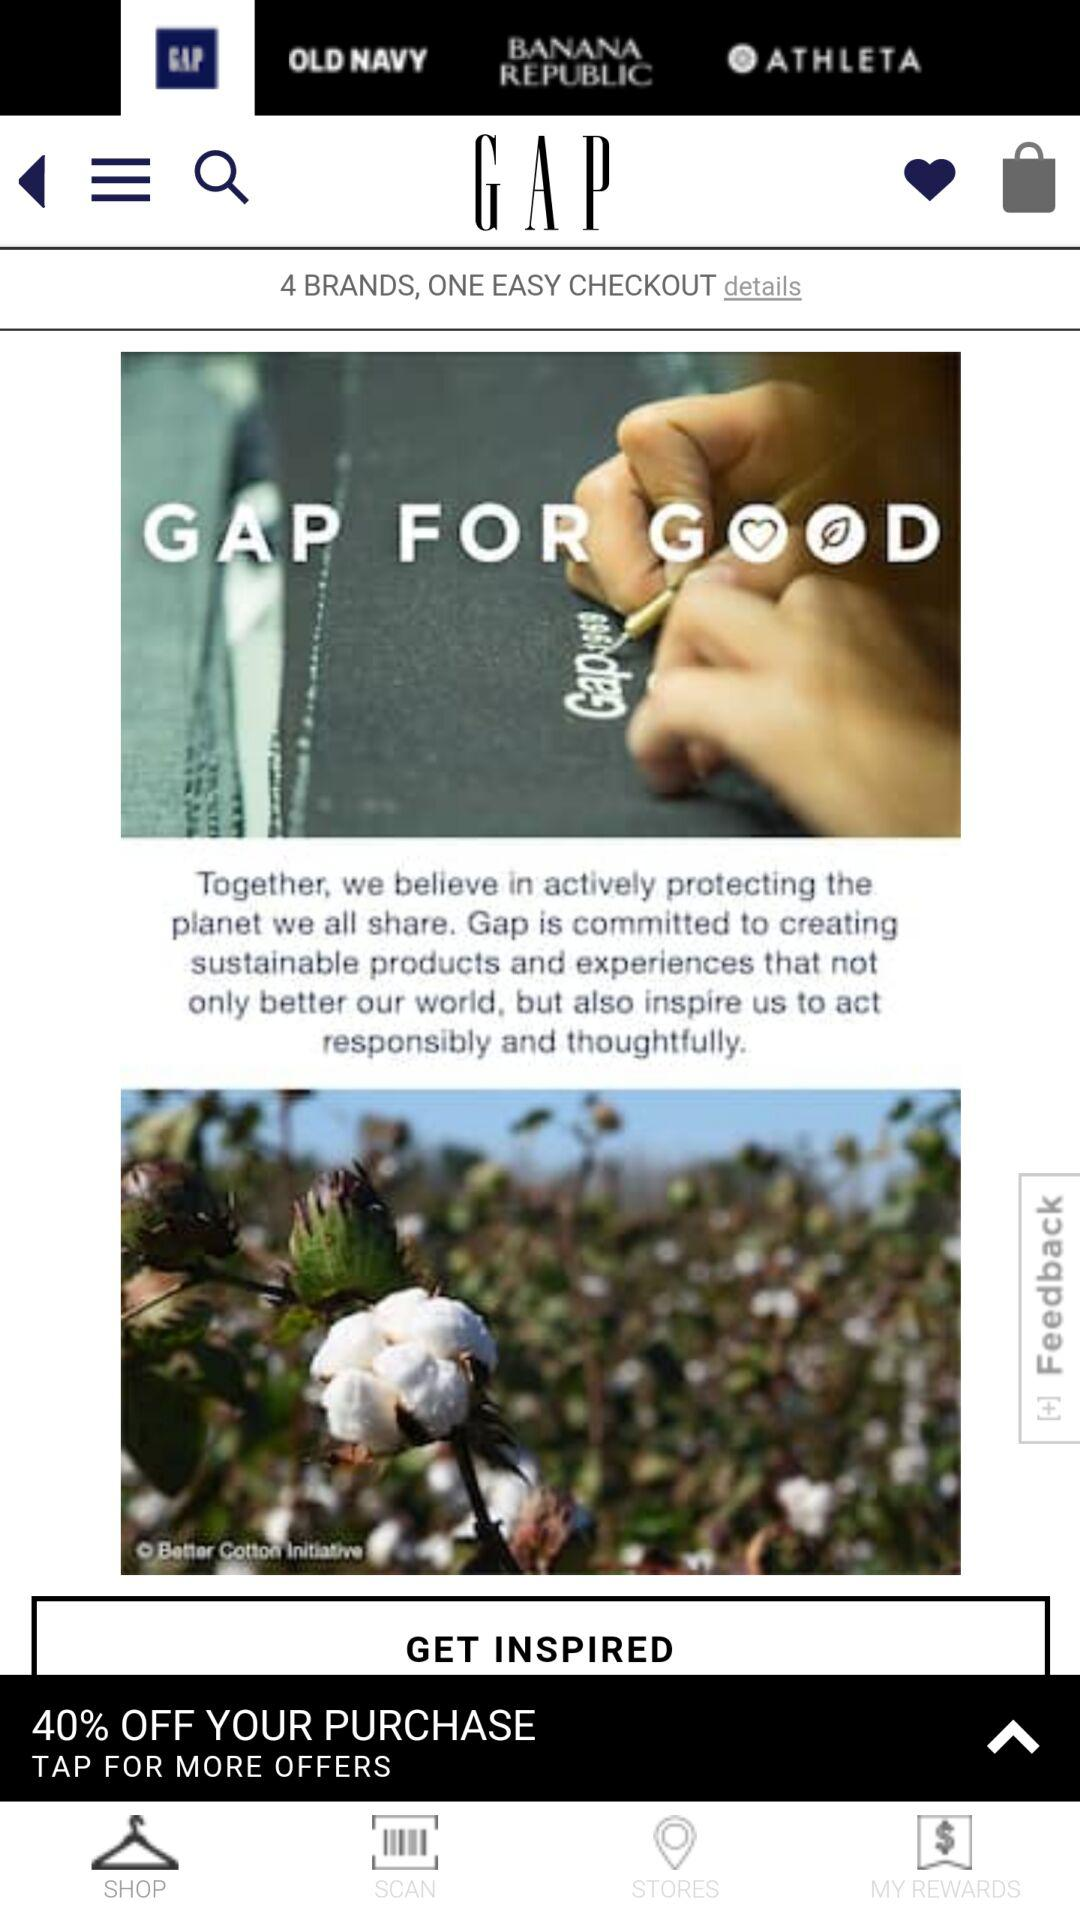How many brands are available to shop for?
Answer the question using a single word or phrase. 4 